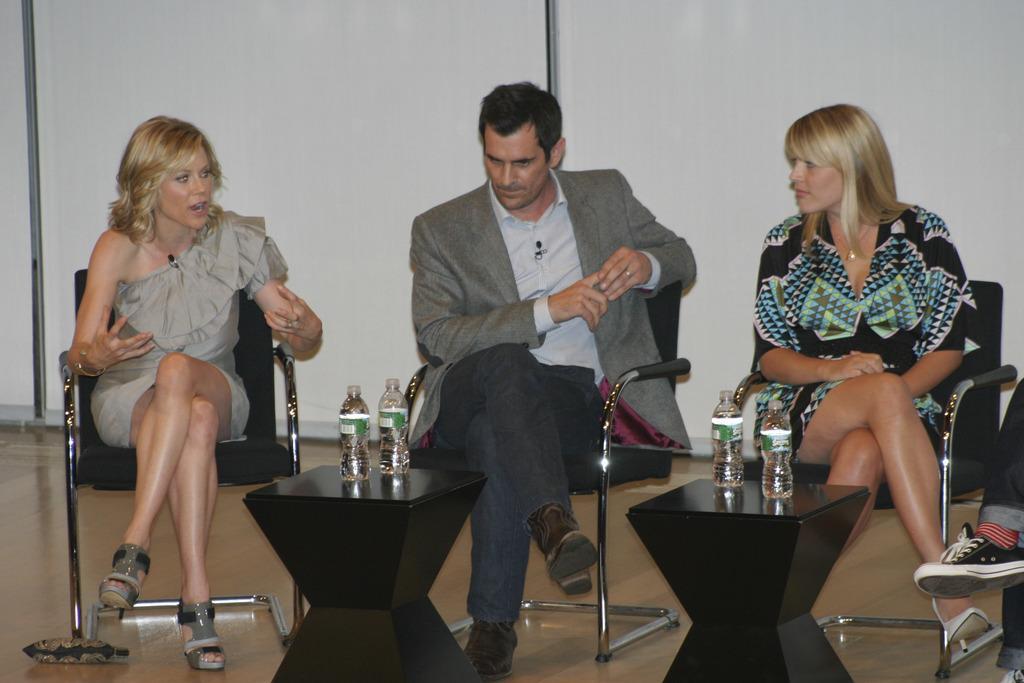Please provide a concise description of this image. In this picture three people are sitting on a chair with black tables in front of them and two water bottles on top of it. 